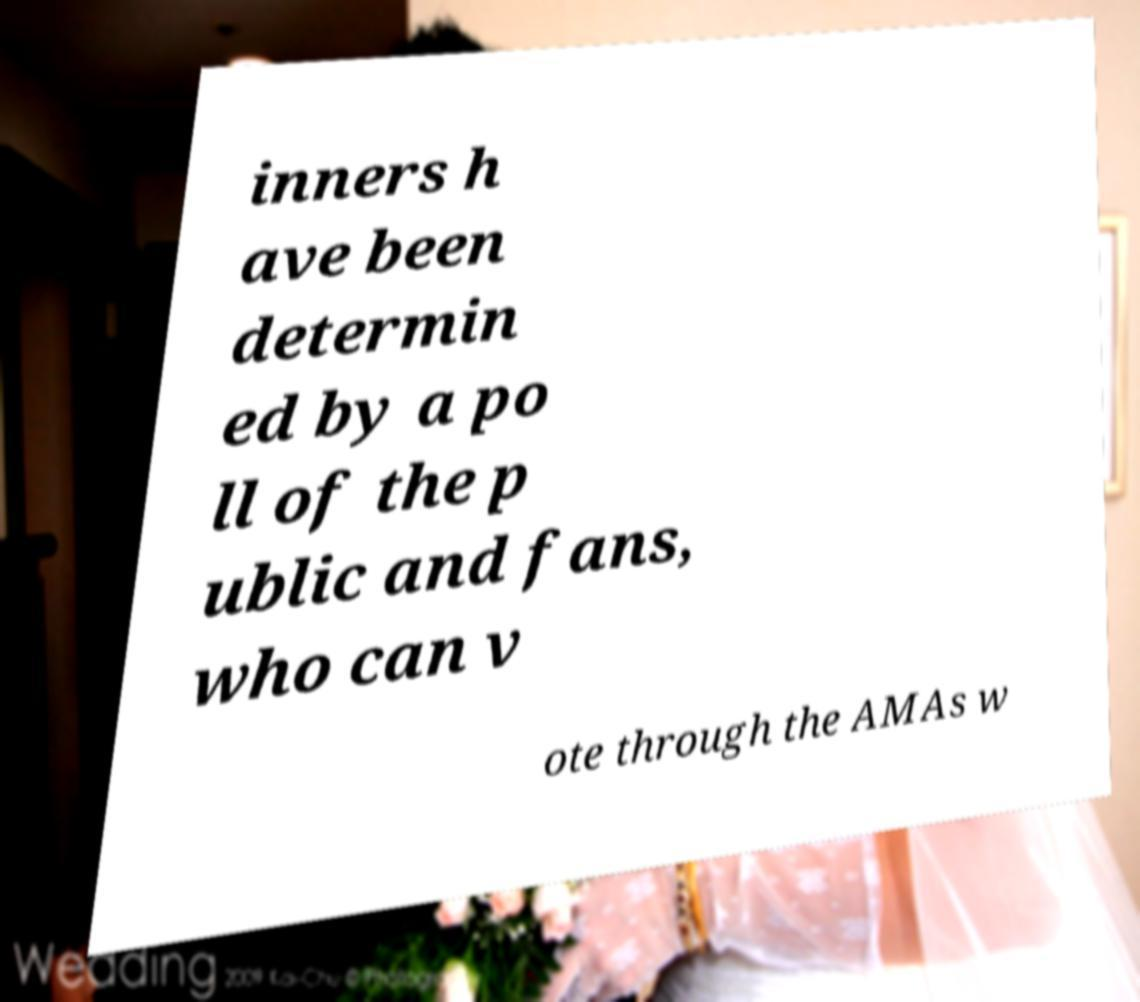I need the written content from this picture converted into text. Can you do that? inners h ave been determin ed by a po ll of the p ublic and fans, who can v ote through the AMAs w 